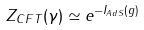Convert formula to latex. <formula><loc_0><loc_0><loc_500><loc_500>Z _ { C F T } ( \gamma ) \simeq e ^ { - I _ { A d S } ( g ) }</formula> 